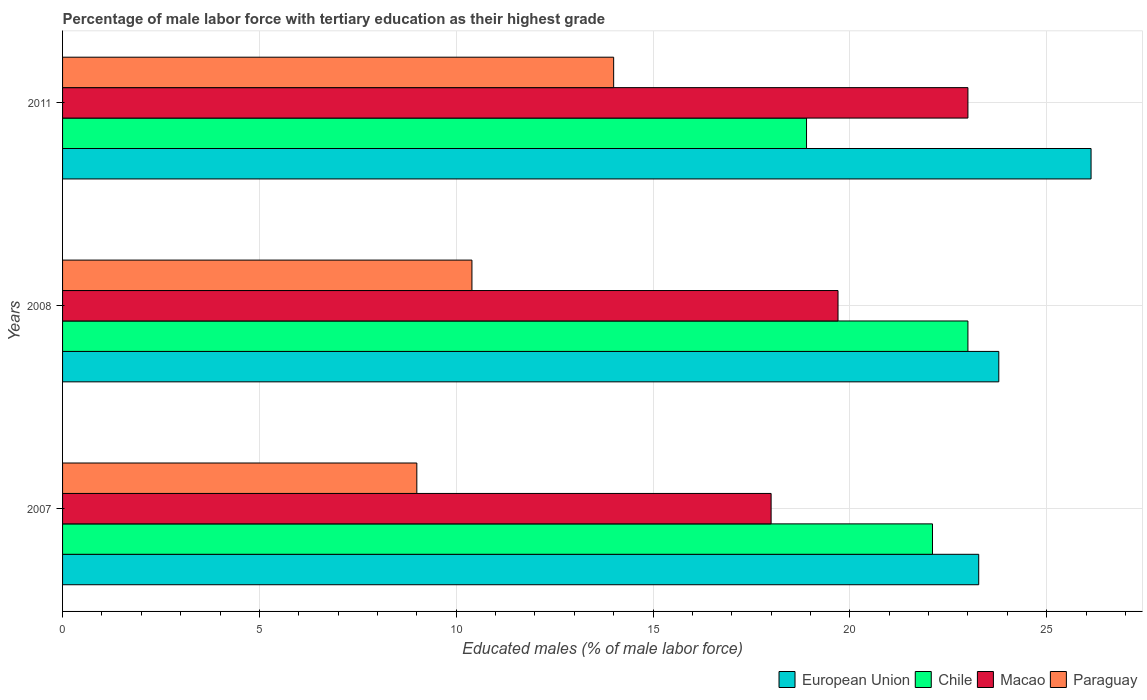How many groups of bars are there?
Give a very brief answer. 3. Are the number of bars on each tick of the Y-axis equal?
Your answer should be very brief. Yes. How many bars are there on the 3rd tick from the top?
Make the answer very short. 4. How many bars are there on the 3rd tick from the bottom?
Keep it short and to the point. 4. What is the percentage of male labor force with tertiary education in Macao in 2011?
Your answer should be compact. 23. Across all years, what is the maximum percentage of male labor force with tertiary education in European Union?
Ensure brevity in your answer.  26.13. In which year was the percentage of male labor force with tertiary education in Macao maximum?
Your answer should be compact. 2011. What is the total percentage of male labor force with tertiary education in European Union in the graph?
Offer a terse response. 73.19. What is the difference between the percentage of male labor force with tertiary education in European Union in 2007 and that in 2011?
Your answer should be very brief. -2.85. What is the difference between the percentage of male labor force with tertiary education in Chile in 2011 and the percentage of male labor force with tertiary education in Paraguay in 2008?
Provide a succinct answer. 8.5. What is the average percentage of male labor force with tertiary education in Paraguay per year?
Your answer should be very brief. 11.13. In the year 2007, what is the difference between the percentage of male labor force with tertiary education in Chile and percentage of male labor force with tertiary education in Macao?
Your answer should be very brief. 4.1. What is the ratio of the percentage of male labor force with tertiary education in Macao in 2007 to that in 2008?
Your answer should be very brief. 0.91. Is the difference between the percentage of male labor force with tertiary education in Chile in 2007 and 2011 greater than the difference between the percentage of male labor force with tertiary education in Macao in 2007 and 2011?
Offer a very short reply. Yes. What is the difference between the highest and the second highest percentage of male labor force with tertiary education in Paraguay?
Your response must be concise. 3.6. What is the difference between the highest and the lowest percentage of male labor force with tertiary education in Chile?
Provide a succinct answer. 4.1. What does the 4th bar from the bottom in 2008 represents?
Provide a short and direct response. Paraguay. Is it the case that in every year, the sum of the percentage of male labor force with tertiary education in Chile and percentage of male labor force with tertiary education in Macao is greater than the percentage of male labor force with tertiary education in European Union?
Provide a short and direct response. Yes. How many years are there in the graph?
Your answer should be compact. 3. Does the graph contain grids?
Offer a terse response. Yes. How many legend labels are there?
Your response must be concise. 4. How are the legend labels stacked?
Provide a succinct answer. Horizontal. What is the title of the graph?
Offer a very short reply. Percentage of male labor force with tertiary education as their highest grade. Does "Papua New Guinea" appear as one of the legend labels in the graph?
Your answer should be very brief. No. What is the label or title of the X-axis?
Your response must be concise. Educated males (% of male labor force). What is the Educated males (% of male labor force) in European Union in 2007?
Provide a short and direct response. 23.27. What is the Educated males (% of male labor force) in Chile in 2007?
Your response must be concise. 22.1. What is the Educated males (% of male labor force) of Macao in 2007?
Provide a succinct answer. 18. What is the Educated males (% of male labor force) in Paraguay in 2007?
Offer a terse response. 9. What is the Educated males (% of male labor force) of European Union in 2008?
Your answer should be compact. 23.78. What is the Educated males (% of male labor force) in Chile in 2008?
Offer a terse response. 23. What is the Educated males (% of male labor force) of Macao in 2008?
Provide a succinct answer. 19.7. What is the Educated males (% of male labor force) in Paraguay in 2008?
Offer a very short reply. 10.4. What is the Educated males (% of male labor force) in European Union in 2011?
Ensure brevity in your answer.  26.13. What is the Educated males (% of male labor force) of Chile in 2011?
Keep it short and to the point. 18.9. What is the Educated males (% of male labor force) of Macao in 2011?
Your response must be concise. 23. Across all years, what is the maximum Educated males (% of male labor force) in European Union?
Ensure brevity in your answer.  26.13. Across all years, what is the maximum Educated males (% of male labor force) in Macao?
Provide a short and direct response. 23. Across all years, what is the maximum Educated males (% of male labor force) of Paraguay?
Give a very brief answer. 14. Across all years, what is the minimum Educated males (% of male labor force) in European Union?
Your answer should be very brief. 23.27. Across all years, what is the minimum Educated males (% of male labor force) in Chile?
Provide a succinct answer. 18.9. Across all years, what is the minimum Educated males (% of male labor force) in Macao?
Offer a very short reply. 18. What is the total Educated males (% of male labor force) of European Union in the graph?
Your answer should be compact. 73.19. What is the total Educated males (% of male labor force) in Macao in the graph?
Ensure brevity in your answer.  60.7. What is the total Educated males (% of male labor force) of Paraguay in the graph?
Offer a very short reply. 33.4. What is the difference between the Educated males (% of male labor force) of European Union in 2007 and that in 2008?
Offer a very short reply. -0.51. What is the difference between the Educated males (% of male labor force) in Macao in 2007 and that in 2008?
Your response must be concise. -1.7. What is the difference between the Educated males (% of male labor force) in Paraguay in 2007 and that in 2008?
Keep it short and to the point. -1.4. What is the difference between the Educated males (% of male labor force) in European Union in 2007 and that in 2011?
Provide a succinct answer. -2.85. What is the difference between the Educated males (% of male labor force) in Chile in 2007 and that in 2011?
Give a very brief answer. 3.2. What is the difference between the Educated males (% of male labor force) in Macao in 2007 and that in 2011?
Your answer should be very brief. -5. What is the difference between the Educated males (% of male labor force) in European Union in 2008 and that in 2011?
Offer a very short reply. -2.34. What is the difference between the Educated males (% of male labor force) in Macao in 2008 and that in 2011?
Ensure brevity in your answer.  -3.3. What is the difference between the Educated males (% of male labor force) of Paraguay in 2008 and that in 2011?
Keep it short and to the point. -3.6. What is the difference between the Educated males (% of male labor force) in European Union in 2007 and the Educated males (% of male labor force) in Chile in 2008?
Make the answer very short. 0.27. What is the difference between the Educated males (% of male labor force) of European Union in 2007 and the Educated males (% of male labor force) of Macao in 2008?
Offer a terse response. 3.57. What is the difference between the Educated males (% of male labor force) in European Union in 2007 and the Educated males (% of male labor force) in Paraguay in 2008?
Offer a very short reply. 12.87. What is the difference between the Educated males (% of male labor force) in Chile in 2007 and the Educated males (% of male labor force) in Paraguay in 2008?
Give a very brief answer. 11.7. What is the difference between the Educated males (% of male labor force) of European Union in 2007 and the Educated males (% of male labor force) of Chile in 2011?
Make the answer very short. 4.37. What is the difference between the Educated males (% of male labor force) in European Union in 2007 and the Educated males (% of male labor force) in Macao in 2011?
Provide a short and direct response. 0.27. What is the difference between the Educated males (% of male labor force) of European Union in 2007 and the Educated males (% of male labor force) of Paraguay in 2011?
Make the answer very short. 9.27. What is the difference between the Educated males (% of male labor force) of Chile in 2007 and the Educated males (% of male labor force) of Paraguay in 2011?
Keep it short and to the point. 8.1. What is the difference between the Educated males (% of male labor force) in Macao in 2007 and the Educated males (% of male labor force) in Paraguay in 2011?
Provide a succinct answer. 4. What is the difference between the Educated males (% of male labor force) in European Union in 2008 and the Educated males (% of male labor force) in Chile in 2011?
Keep it short and to the point. 4.88. What is the difference between the Educated males (% of male labor force) in European Union in 2008 and the Educated males (% of male labor force) in Macao in 2011?
Provide a short and direct response. 0.78. What is the difference between the Educated males (% of male labor force) in European Union in 2008 and the Educated males (% of male labor force) in Paraguay in 2011?
Make the answer very short. 9.78. What is the difference between the Educated males (% of male labor force) of Macao in 2008 and the Educated males (% of male labor force) of Paraguay in 2011?
Offer a very short reply. 5.7. What is the average Educated males (% of male labor force) in European Union per year?
Offer a very short reply. 24.4. What is the average Educated males (% of male labor force) of Chile per year?
Offer a terse response. 21.33. What is the average Educated males (% of male labor force) of Macao per year?
Give a very brief answer. 20.23. What is the average Educated males (% of male labor force) in Paraguay per year?
Offer a terse response. 11.13. In the year 2007, what is the difference between the Educated males (% of male labor force) in European Union and Educated males (% of male labor force) in Chile?
Your answer should be compact. 1.17. In the year 2007, what is the difference between the Educated males (% of male labor force) in European Union and Educated males (% of male labor force) in Macao?
Ensure brevity in your answer.  5.27. In the year 2007, what is the difference between the Educated males (% of male labor force) in European Union and Educated males (% of male labor force) in Paraguay?
Your response must be concise. 14.27. In the year 2007, what is the difference between the Educated males (% of male labor force) of Macao and Educated males (% of male labor force) of Paraguay?
Give a very brief answer. 9. In the year 2008, what is the difference between the Educated males (% of male labor force) in European Union and Educated males (% of male labor force) in Chile?
Your response must be concise. 0.78. In the year 2008, what is the difference between the Educated males (% of male labor force) in European Union and Educated males (% of male labor force) in Macao?
Your response must be concise. 4.08. In the year 2008, what is the difference between the Educated males (% of male labor force) in European Union and Educated males (% of male labor force) in Paraguay?
Offer a very short reply. 13.38. In the year 2008, what is the difference between the Educated males (% of male labor force) of Chile and Educated males (% of male labor force) of Paraguay?
Ensure brevity in your answer.  12.6. In the year 2011, what is the difference between the Educated males (% of male labor force) in European Union and Educated males (% of male labor force) in Chile?
Offer a terse response. 7.23. In the year 2011, what is the difference between the Educated males (% of male labor force) of European Union and Educated males (% of male labor force) of Macao?
Provide a short and direct response. 3.13. In the year 2011, what is the difference between the Educated males (% of male labor force) of European Union and Educated males (% of male labor force) of Paraguay?
Offer a terse response. 12.13. In the year 2011, what is the difference between the Educated males (% of male labor force) of Chile and Educated males (% of male labor force) of Macao?
Make the answer very short. -4.1. In the year 2011, what is the difference between the Educated males (% of male labor force) of Macao and Educated males (% of male labor force) of Paraguay?
Make the answer very short. 9. What is the ratio of the Educated males (% of male labor force) in European Union in 2007 to that in 2008?
Keep it short and to the point. 0.98. What is the ratio of the Educated males (% of male labor force) of Chile in 2007 to that in 2008?
Your answer should be very brief. 0.96. What is the ratio of the Educated males (% of male labor force) of Macao in 2007 to that in 2008?
Offer a very short reply. 0.91. What is the ratio of the Educated males (% of male labor force) of Paraguay in 2007 to that in 2008?
Make the answer very short. 0.87. What is the ratio of the Educated males (% of male labor force) in European Union in 2007 to that in 2011?
Your response must be concise. 0.89. What is the ratio of the Educated males (% of male labor force) of Chile in 2007 to that in 2011?
Your answer should be very brief. 1.17. What is the ratio of the Educated males (% of male labor force) in Macao in 2007 to that in 2011?
Provide a short and direct response. 0.78. What is the ratio of the Educated males (% of male labor force) in Paraguay in 2007 to that in 2011?
Your response must be concise. 0.64. What is the ratio of the Educated males (% of male labor force) in European Union in 2008 to that in 2011?
Make the answer very short. 0.91. What is the ratio of the Educated males (% of male labor force) in Chile in 2008 to that in 2011?
Offer a terse response. 1.22. What is the ratio of the Educated males (% of male labor force) of Macao in 2008 to that in 2011?
Offer a very short reply. 0.86. What is the ratio of the Educated males (% of male labor force) in Paraguay in 2008 to that in 2011?
Your answer should be very brief. 0.74. What is the difference between the highest and the second highest Educated males (% of male labor force) of European Union?
Your answer should be compact. 2.34. What is the difference between the highest and the second highest Educated males (% of male labor force) in Chile?
Give a very brief answer. 0.9. What is the difference between the highest and the second highest Educated males (% of male labor force) in Paraguay?
Ensure brevity in your answer.  3.6. What is the difference between the highest and the lowest Educated males (% of male labor force) in European Union?
Offer a terse response. 2.85. What is the difference between the highest and the lowest Educated males (% of male labor force) of Chile?
Provide a short and direct response. 4.1. What is the difference between the highest and the lowest Educated males (% of male labor force) of Paraguay?
Provide a short and direct response. 5. 